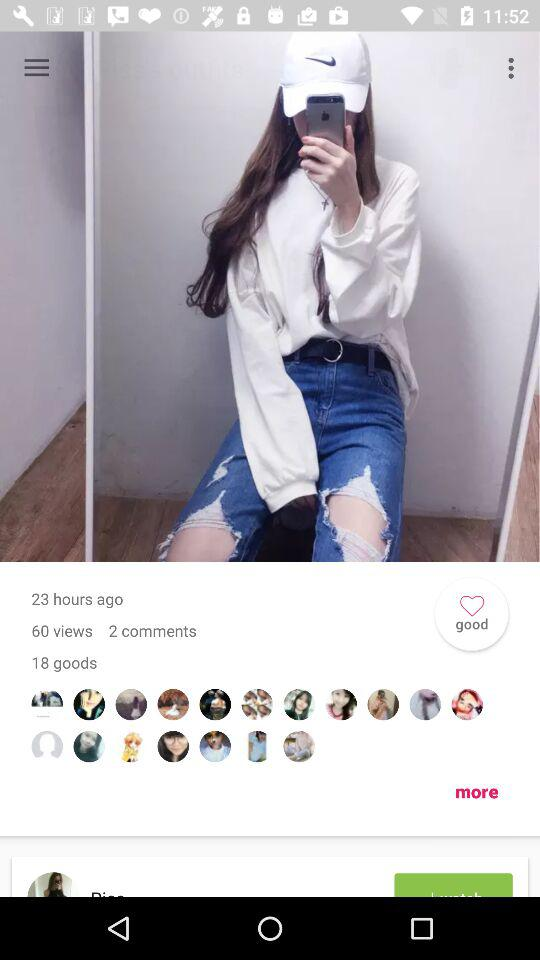How many more people have commented on this post than liked it?
Answer the question using a single word or phrase. 16 